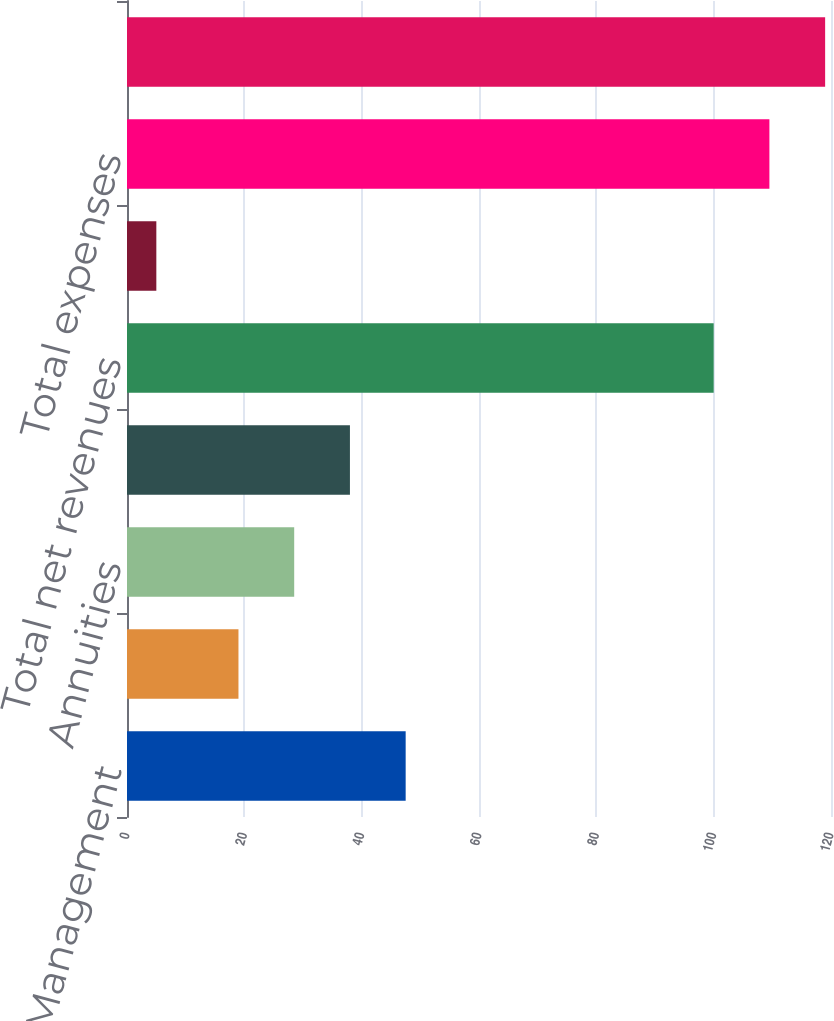Convert chart. <chart><loc_0><loc_0><loc_500><loc_500><bar_chart><fcel>Advice & Wealth Management<fcel>Asset Management<fcel>Annuities<fcel>Protection<fcel>Total net revenues<fcel>Corporate & Other<fcel>Total expenses<fcel>Pretax income (loss)<nl><fcel>47.5<fcel>19<fcel>28.5<fcel>38<fcel>100<fcel>5<fcel>109.5<fcel>119<nl></chart> 